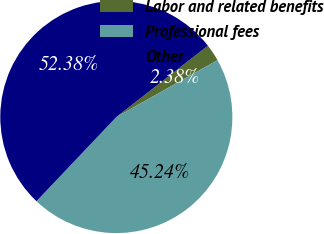<chart> <loc_0><loc_0><loc_500><loc_500><pie_chart><fcel>Labor and related benefits<fcel>Professional fees<fcel>Other<nl><fcel>2.38%<fcel>45.24%<fcel>52.38%<nl></chart> 